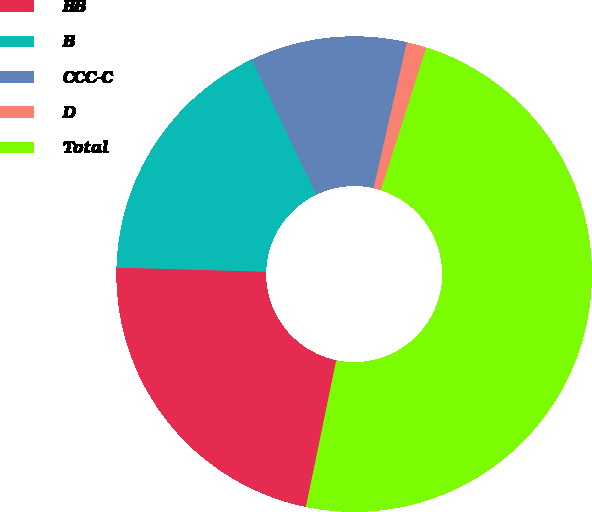Convert chart to OTSL. <chart><loc_0><loc_0><loc_500><loc_500><pie_chart><fcel>BB<fcel>B<fcel>CCC-C<fcel>D<fcel>Total<nl><fcel>22.19%<fcel>17.49%<fcel>10.63%<fcel>1.35%<fcel>48.33%<nl></chart> 